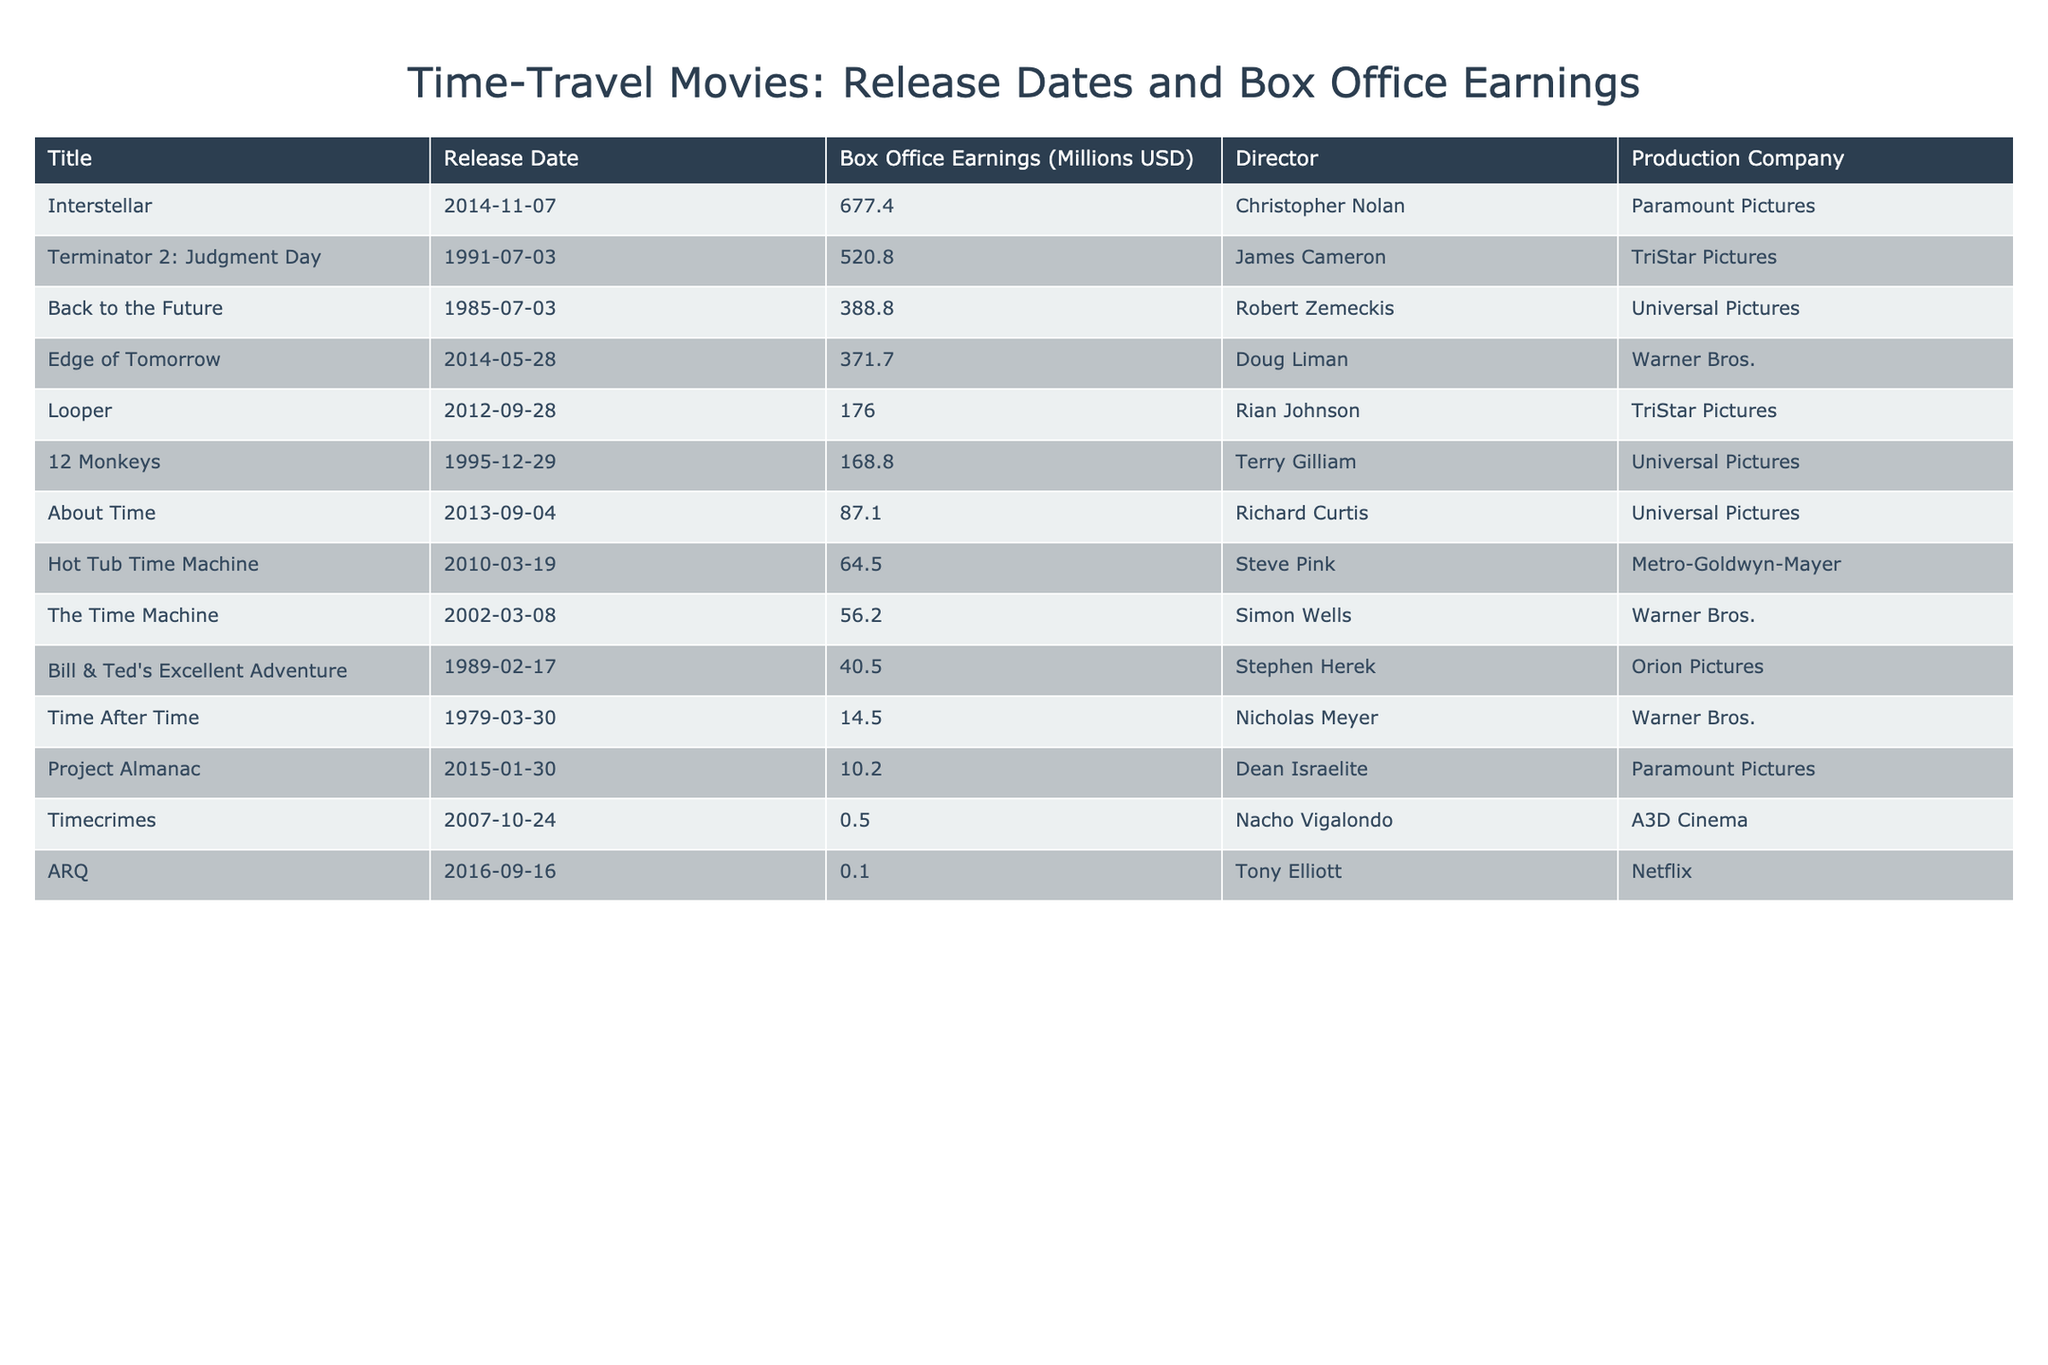What is the highest box office earning among the time-travel films listed? The table shows the box office earnings for various time-travel films, and by scanning the "Box Office Earnings (Millions USD)" column, we can see that "Interstellar" has the highest earning of 677.4 million USD.
Answer: 677.4 million USD Which movie was released in 1989? By checking the "Release Date" column for the year 1989, we see that "Bill & Ted's Excellent Adventure" was released then.
Answer: Bill & Ted's Excellent Adventure How much did "Timecrimes" earn at the box office? The table includes a specific row for "Timecrimes," and the corresponding box office earning listed is 0.5 million USD.
Answer: 0.5 million USD What is the average box office earnings for all the movies listed? To find the average, we first sum all the box office earnings: 388.8 + 520.8 + 0.5 + 168.8 + 371.7 + 176 + 677.4 + 87.1 + 10.2 + 40.5 + 56.2 + 14.5 + 0.1 + 64.5 = 2006.8 million USD. With 14 movies in total, the average is 2006.8 / 14 = approximately 143.4 million USD.
Answer: 143.4 million USD Did any film released after 2010 earn less than 1 million USD? We can look at the films released after 2010 and check their box office earnings; "ARQ" earned only 0.1 million USD, confirming that yes, there was a film that earned less than 1 million USD.
Answer: Yes What is the difference in box office earnings between "Terminator 2: Judgment Day" and "12 Monkeys"? The earnings for "Terminator 2" are 520.8 million USD, and for "12 Monkeys" it is 168.8 million USD. The difference is 520.8 - 168.8 = 352 million USD.
Answer: 352 million USD How many films have box office earnings greater than 100 million USD? By examining the "Box Office Earnings" column, we list the movies earning over 100 million USD: "Back to the Future," "Terminator 2: Judgment Day," "Interstellar," "Edge of Tomorrow," "Looper," and "12 Monkeys," totaling 6 films.
Answer: 6 films What movie directed by Christopher Nolan made the most money at the box office? The only movie directed by Christopher Nolan listed is "Interstellar," which has the highest box office earnings of 677.4 million USD.
Answer: Interstellar 